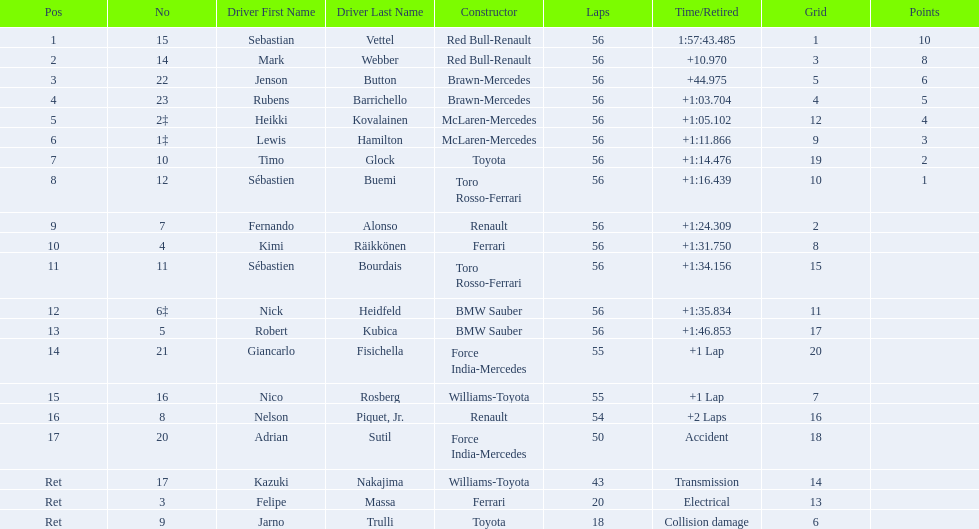Who are all of the drivers? Sebastian Vettel, Mark Webber, Jenson Button, Rubens Barrichello, Heikki Kovalainen, Lewis Hamilton, Timo Glock, Sébastien Buemi, Fernando Alonso, Kimi Räikkönen, Sébastien Bourdais, Nick Heidfeld, Robert Kubica, Giancarlo Fisichella, Nico Rosberg, Nelson Piquet, Jr., Adrian Sutil, Kazuki Nakajima, Felipe Massa, Jarno Trulli. Who were their constructors? Red Bull-Renault, Red Bull-Renault, Brawn-Mercedes, Brawn-Mercedes, McLaren-Mercedes, McLaren-Mercedes, Toyota, Toro Rosso-Ferrari, Renault, Ferrari, Toro Rosso-Ferrari, BMW Sauber, BMW Sauber, Force India-Mercedes, Williams-Toyota, Renault, Force India-Mercedes, Williams-Toyota, Ferrari, Toyota. Who was the first listed driver to not drive a ferrari?? Sebastian Vettel. 